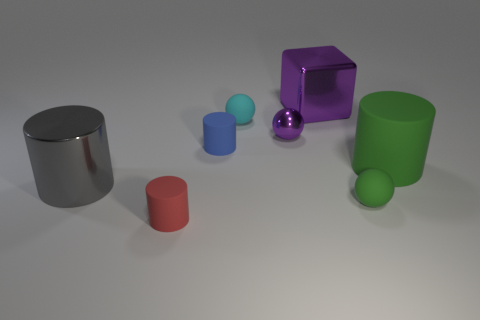Subtract 1 cylinders. How many cylinders are left? 3 Subtract all purple cylinders. Subtract all red balls. How many cylinders are left? 4 Add 1 tiny blue rubber cylinders. How many objects exist? 9 Subtract all cubes. How many objects are left? 7 Subtract 0 brown blocks. How many objects are left? 8 Subtract all cyan matte things. Subtract all gray metallic cylinders. How many objects are left? 6 Add 5 cyan objects. How many cyan objects are left? 6 Add 2 blue blocks. How many blue blocks exist? 2 